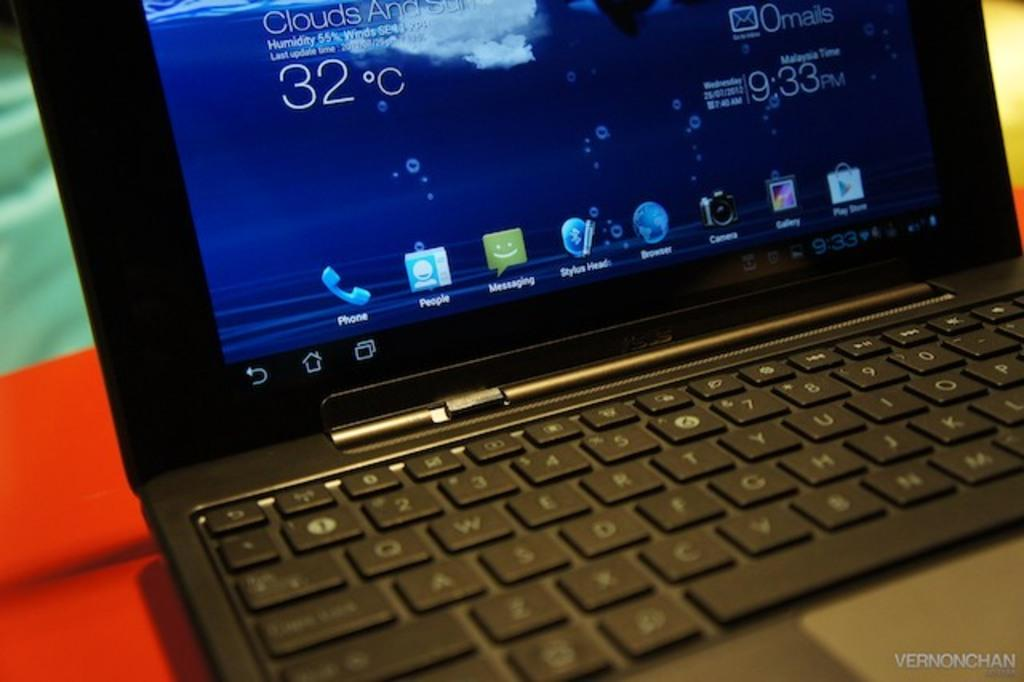<image>
Summarize the visual content of the image. A laptop screen showing the weather as 32 degrees Celsius. 